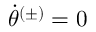Convert formula to latex. <formula><loc_0><loc_0><loc_500><loc_500>\ D o t { \theta } ^ { ( \pm ) } = 0</formula> 